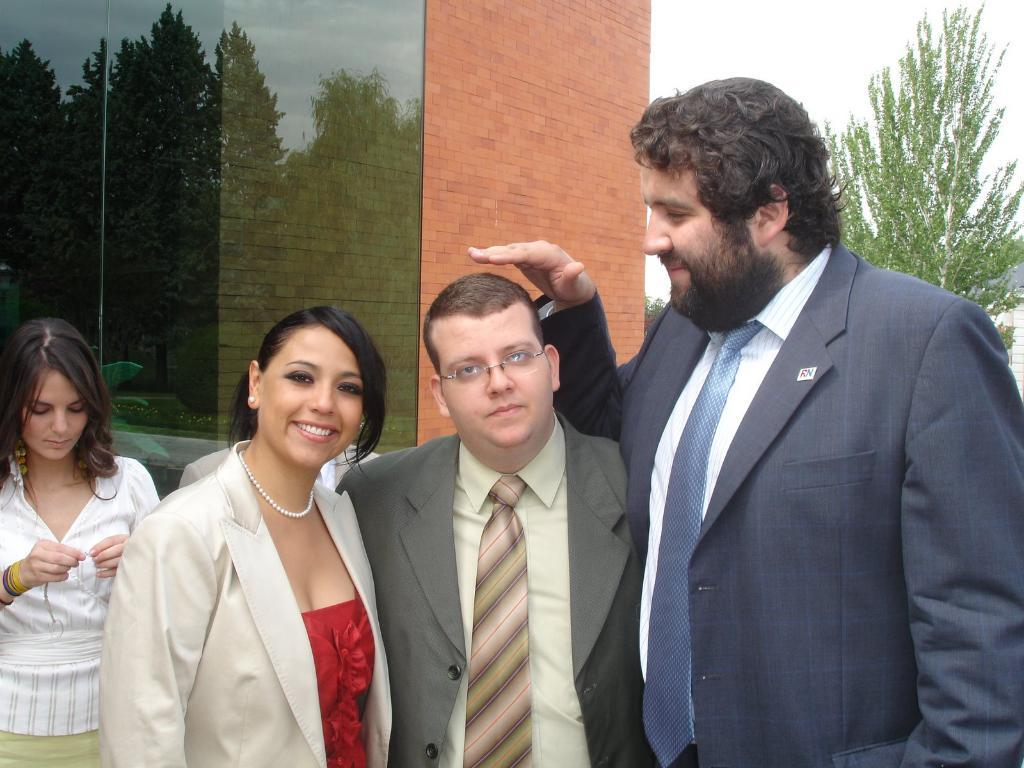How many people are in the image? There is a group of people in the image, but the exact number is not specified. What can be seen in the background of the image? There is a building, trees, and the sky visible in the background of the image. What type of snail is responsible for the distribution of the writer's work in the image? There is no snail or writer present in the image, so it is not possible to answer that question. 